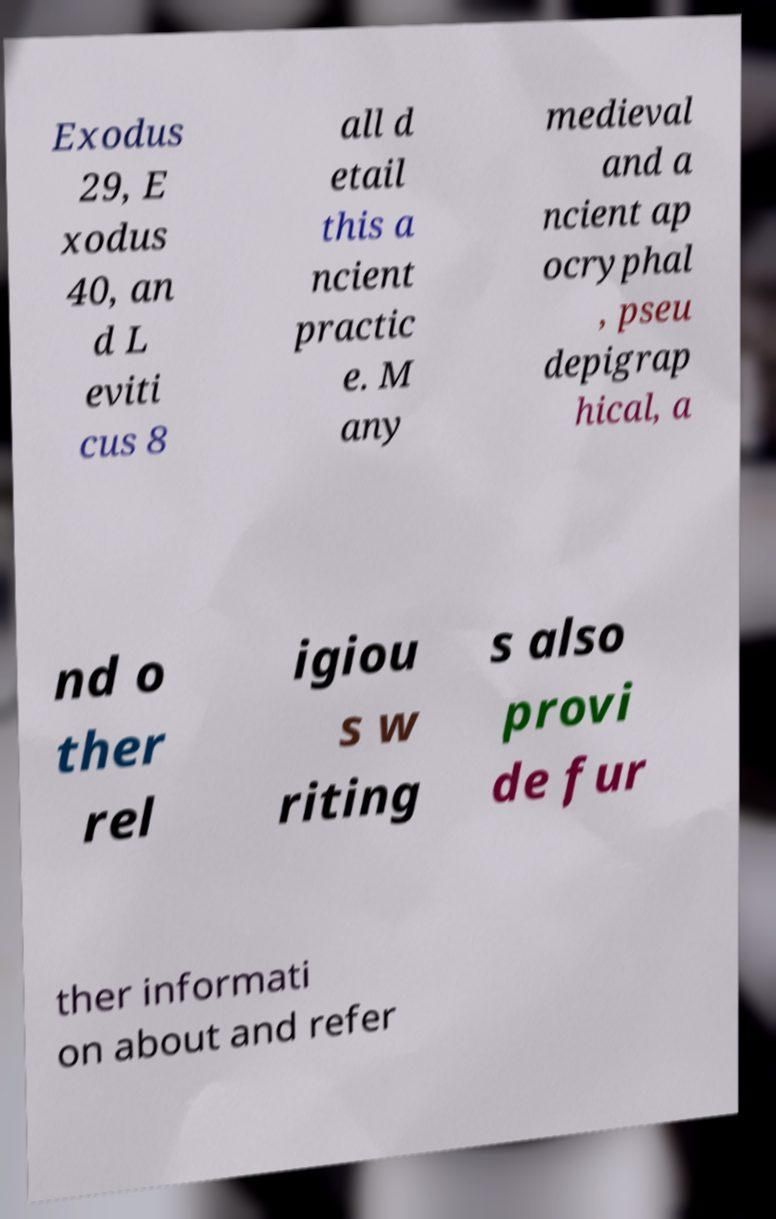What messages or text are displayed in this image? I need them in a readable, typed format. Exodus 29, E xodus 40, an d L eviti cus 8 all d etail this a ncient practic e. M any medieval and a ncient ap ocryphal , pseu depigrap hical, a nd o ther rel igiou s w riting s also provi de fur ther informati on about and refer 